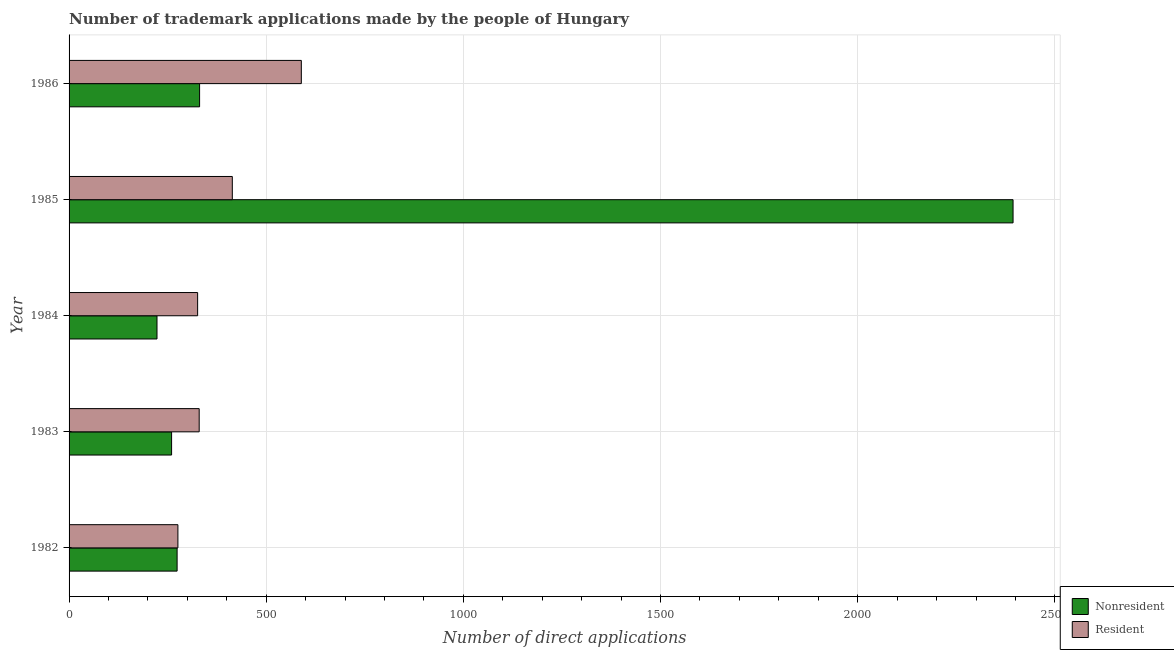How many different coloured bars are there?
Make the answer very short. 2. How many bars are there on the 1st tick from the top?
Ensure brevity in your answer.  2. How many bars are there on the 4th tick from the bottom?
Offer a very short reply. 2. What is the label of the 2nd group of bars from the top?
Your answer should be compact. 1985. In how many cases, is the number of bars for a given year not equal to the number of legend labels?
Offer a very short reply. 0. What is the number of trademark applications made by residents in 1982?
Offer a very short reply. 276. Across all years, what is the maximum number of trademark applications made by non residents?
Provide a short and direct response. 2394. Across all years, what is the minimum number of trademark applications made by residents?
Make the answer very short. 276. In which year was the number of trademark applications made by non residents maximum?
Ensure brevity in your answer.  1985. In which year was the number of trademark applications made by residents minimum?
Your answer should be compact. 1982. What is the total number of trademark applications made by non residents in the graph?
Ensure brevity in your answer.  3482. What is the difference between the number of trademark applications made by non residents in 1983 and that in 1986?
Make the answer very short. -71. What is the difference between the number of trademark applications made by non residents in 1984 and the number of trademark applications made by residents in 1983?
Offer a very short reply. -107. What is the average number of trademark applications made by non residents per year?
Make the answer very short. 696.4. In the year 1985, what is the difference between the number of trademark applications made by residents and number of trademark applications made by non residents?
Provide a succinct answer. -1980. What is the ratio of the number of trademark applications made by residents in 1984 to that in 1985?
Provide a succinct answer. 0.79. Is the number of trademark applications made by residents in 1982 less than that in 1984?
Keep it short and to the point. Yes. What is the difference between the highest and the second highest number of trademark applications made by residents?
Offer a very short reply. 175. What is the difference between the highest and the lowest number of trademark applications made by non residents?
Make the answer very short. 2171. In how many years, is the number of trademark applications made by non residents greater than the average number of trademark applications made by non residents taken over all years?
Your answer should be compact. 1. Is the sum of the number of trademark applications made by non residents in 1982 and 1986 greater than the maximum number of trademark applications made by residents across all years?
Your answer should be compact. Yes. What does the 2nd bar from the top in 1983 represents?
Provide a short and direct response. Nonresident. What does the 2nd bar from the bottom in 1984 represents?
Your answer should be very brief. Resident. How many bars are there?
Offer a terse response. 10. Are all the bars in the graph horizontal?
Your response must be concise. Yes. How many years are there in the graph?
Your response must be concise. 5. What is the difference between two consecutive major ticks on the X-axis?
Make the answer very short. 500. Are the values on the major ticks of X-axis written in scientific E-notation?
Ensure brevity in your answer.  No. Does the graph contain grids?
Your answer should be compact. Yes. Where does the legend appear in the graph?
Provide a short and direct response. Bottom right. How many legend labels are there?
Ensure brevity in your answer.  2. What is the title of the graph?
Provide a succinct answer. Number of trademark applications made by the people of Hungary. Does "Primary" appear as one of the legend labels in the graph?
Keep it short and to the point. No. What is the label or title of the X-axis?
Offer a terse response. Number of direct applications. What is the label or title of the Y-axis?
Give a very brief answer. Year. What is the Number of direct applications of Nonresident in 1982?
Your answer should be compact. 274. What is the Number of direct applications of Resident in 1982?
Provide a succinct answer. 276. What is the Number of direct applications in Nonresident in 1983?
Your answer should be very brief. 260. What is the Number of direct applications in Resident in 1983?
Give a very brief answer. 330. What is the Number of direct applications of Nonresident in 1984?
Offer a terse response. 223. What is the Number of direct applications of Resident in 1984?
Ensure brevity in your answer.  326. What is the Number of direct applications in Nonresident in 1985?
Your response must be concise. 2394. What is the Number of direct applications of Resident in 1985?
Keep it short and to the point. 414. What is the Number of direct applications of Nonresident in 1986?
Offer a terse response. 331. What is the Number of direct applications of Resident in 1986?
Your answer should be very brief. 589. Across all years, what is the maximum Number of direct applications in Nonresident?
Provide a short and direct response. 2394. Across all years, what is the maximum Number of direct applications of Resident?
Provide a succinct answer. 589. Across all years, what is the minimum Number of direct applications in Nonresident?
Your response must be concise. 223. Across all years, what is the minimum Number of direct applications in Resident?
Provide a succinct answer. 276. What is the total Number of direct applications in Nonresident in the graph?
Provide a succinct answer. 3482. What is the total Number of direct applications in Resident in the graph?
Ensure brevity in your answer.  1935. What is the difference between the Number of direct applications of Resident in 1982 and that in 1983?
Offer a very short reply. -54. What is the difference between the Number of direct applications of Nonresident in 1982 and that in 1984?
Keep it short and to the point. 51. What is the difference between the Number of direct applications of Resident in 1982 and that in 1984?
Your answer should be compact. -50. What is the difference between the Number of direct applications of Nonresident in 1982 and that in 1985?
Offer a terse response. -2120. What is the difference between the Number of direct applications of Resident in 1982 and that in 1985?
Provide a succinct answer. -138. What is the difference between the Number of direct applications in Nonresident in 1982 and that in 1986?
Ensure brevity in your answer.  -57. What is the difference between the Number of direct applications of Resident in 1982 and that in 1986?
Make the answer very short. -313. What is the difference between the Number of direct applications of Nonresident in 1983 and that in 1985?
Your answer should be compact. -2134. What is the difference between the Number of direct applications in Resident in 1983 and that in 1985?
Provide a succinct answer. -84. What is the difference between the Number of direct applications in Nonresident in 1983 and that in 1986?
Keep it short and to the point. -71. What is the difference between the Number of direct applications of Resident in 1983 and that in 1986?
Your answer should be very brief. -259. What is the difference between the Number of direct applications of Nonresident in 1984 and that in 1985?
Make the answer very short. -2171. What is the difference between the Number of direct applications of Resident in 1984 and that in 1985?
Provide a short and direct response. -88. What is the difference between the Number of direct applications in Nonresident in 1984 and that in 1986?
Offer a very short reply. -108. What is the difference between the Number of direct applications in Resident in 1984 and that in 1986?
Your answer should be very brief. -263. What is the difference between the Number of direct applications in Nonresident in 1985 and that in 1986?
Provide a short and direct response. 2063. What is the difference between the Number of direct applications of Resident in 1985 and that in 1986?
Provide a succinct answer. -175. What is the difference between the Number of direct applications in Nonresident in 1982 and the Number of direct applications in Resident in 1983?
Provide a succinct answer. -56. What is the difference between the Number of direct applications of Nonresident in 1982 and the Number of direct applications of Resident in 1984?
Your response must be concise. -52. What is the difference between the Number of direct applications in Nonresident in 1982 and the Number of direct applications in Resident in 1985?
Give a very brief answer. -140. What is the difference between the Number of direct applications of Nonresident in 1982 and the Number of direct applications of Resident in 1986?
Your response must be concise. -315. What is the difference between the Number of direct applications in Nonresident in 1983 and the Number of direct applications in Resident in 1984?
Your response must be concise. -66. What is the difference between the Number of direct applications of Nonresident in 1983 and the Number of direct applications of Resident in 1985?
Offer a very short reply. -154. What is the difference between the Number of direct applications of Nonresident in 1983 and the Number of direct applications of Resident in 1986?
Provide a short and direct response. -329. What is the difference between the Number of direct applications in Nonresident in 1984 and the Number of direct applications in Resident in 1985?
Offer a very short reply. -191. What is the difference between the Number of direct applications of Nonresident in 1984 and the Number of direct applications of Resident in 1986?
Ensure brevity in your answer.  -366. What is the difference between the Number of direct applications in Nonresident in 1985 and the Number of direct applications in Resident in 1986?
Keep it short and to the point. 1805. What is the average Number of direct applications in Nonresident per year?
Make the answer very short. 696.4. What is the average Number of direct applications in Resident per year?
Your answer should be compact. 387. In the year 1982, what is the difference between the Number of direct applications of Nonresident and Number of direct applications of Resident?
Make the answer very short. -2. In the year 1983, what is the difference between the Number of direct applications in Nonresident and Number of direct applications in Resident?
Offer a terse response. -70. In the year 1984, what is the difference between the Number of direct applications of Nonresident and Number of direct applications of Resident?
Give a very brief answer. -103. In the year 1985, what is the difference between the Number of direct applications in Nonresident and Number of direct applications in Resident?
Your response must be concise. 1980. In the year 1986, what is the difference between the Number of direct applications in Nonresident and Number of direct applications in Resident?
Provide a succinct answer. -258. What is the ratio of the Number of direct applications in Nonresident in 1982 to that in 1983?
Your answer should be compact. 1.05. What is the ratio of the Number of direct applications in Resident in 1982 to that in 1983?
Your response must be concise. 0.84. What is the ratio of the Number of direct applications of Nonresident in 1982 to that in 1984?
Provide a succinct answer. 1.23. What is the ratio of the Number of direct applications of Resident in 1982 to that in 1984?
Offer a very short reply. 0.85. What is the ratio of the Number of direct applications in Nonresident in 1982 to that in 1985?
Keep it short and to the point. 0.11. What is the ratio of the Number of direct applications in Nonresident in 1982 to that in 1986?
Provide a succinct answer. 0.83. What is the ratio of the Number of direct applications of Resident in 1982 to that in 1986?
Keep it short and to the point. 0.47. What is the ratio of the Number of direct applications of Nonresident in 1983 to that in 1984?
Provide a succinct answer. 1.17. What is the ratio of the Number of direct applications of Resident in 1983 to that in 1984?
Your answer should be very brief. 1.01. What is the ratio of the Number of direct applications in Nonresident in 1983 to that in 1985?
Your response must be concise. 0.11. What is the ratio of the Number of direct applications of Resident in 1983 to that in 1985?
Your answer should be very brief. 0.8. What is the ratio of the Number of direct applications in Nonresident in 1983 to that in 1986?
Give a very brief answer. 0.79. What is the ratio of the Number of direct applications in Resident in 1983 to that in 1986?
Ensure brevity in your answer.  0.56. What is the ratio of the Number of direct applications of Nonresident in 1984 to that in 1985?
Your answer should be very brief. 0.09. What is the ratio of the Number of direct applications in Resident in 1984 to that in 1985?
Offer a very short reply. 0.79. What is the ratio of the Number of direct applications of Nonresident in 1984 to that in 1986?
Make the answer very short. 0.67. What is the ratio of the Number of direct applications of Resident in 1984 to that in 1986?
Ensure brevity in your answer.  0.55. What is the ratio of the Number of direct applications in Nonresident in 1985 to that in 1986?
Your answer should be very brief. 7.23. What is the ratio of the Number of direct applications in Resident in 1985 to that in 1986?
Your answer should be very brief. 0.7. What is the difference between the highest and the second highest Number of direct applications of Nonresident?
Keep it short and to the point. 2063. What is the difference between the highest and the second highest Number of direct applications of Resident?
Your response must be concise. 175. What is the difference between the highest and the lowest Number of direct applications in Nonresident?
Ensure brevity in your answer.  2171. What is the difference between the highest and the lowest Number of direct applications in Resident?
Give a very brief answer. 313. 